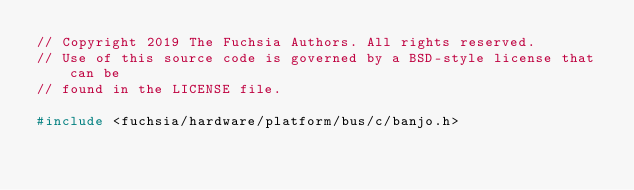Convert code to text. <code><loc_0><loc_0><loc_500><loc_500><_C++_>// Copyright 2019 The Fuchsia Authors. All rights reserved.
// Use of this source code is governed by a BSD-style license that can be
// found in the LICENSE file.

#include <fuchsia/hardware/platform/bus/c/banjo.h></code> 